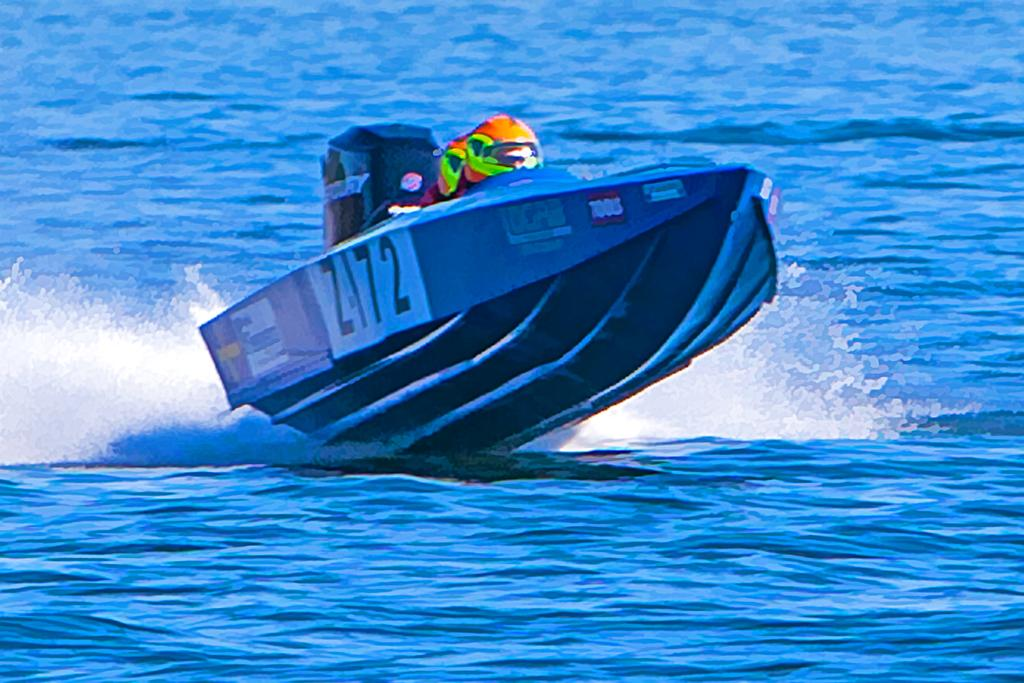Who is present in the image? There is a person in the image. What activity is the person engaged in? The person is taking a motor boat ride. Where is the motor boat located? The motor boat is on a river. What is the color of the water in the river? The water in the river is blue. What type of hat is the person wearing while riding the motor boat? There is no hat visible in the image, so it cannot be determined what type of hat the person might be wearing. 